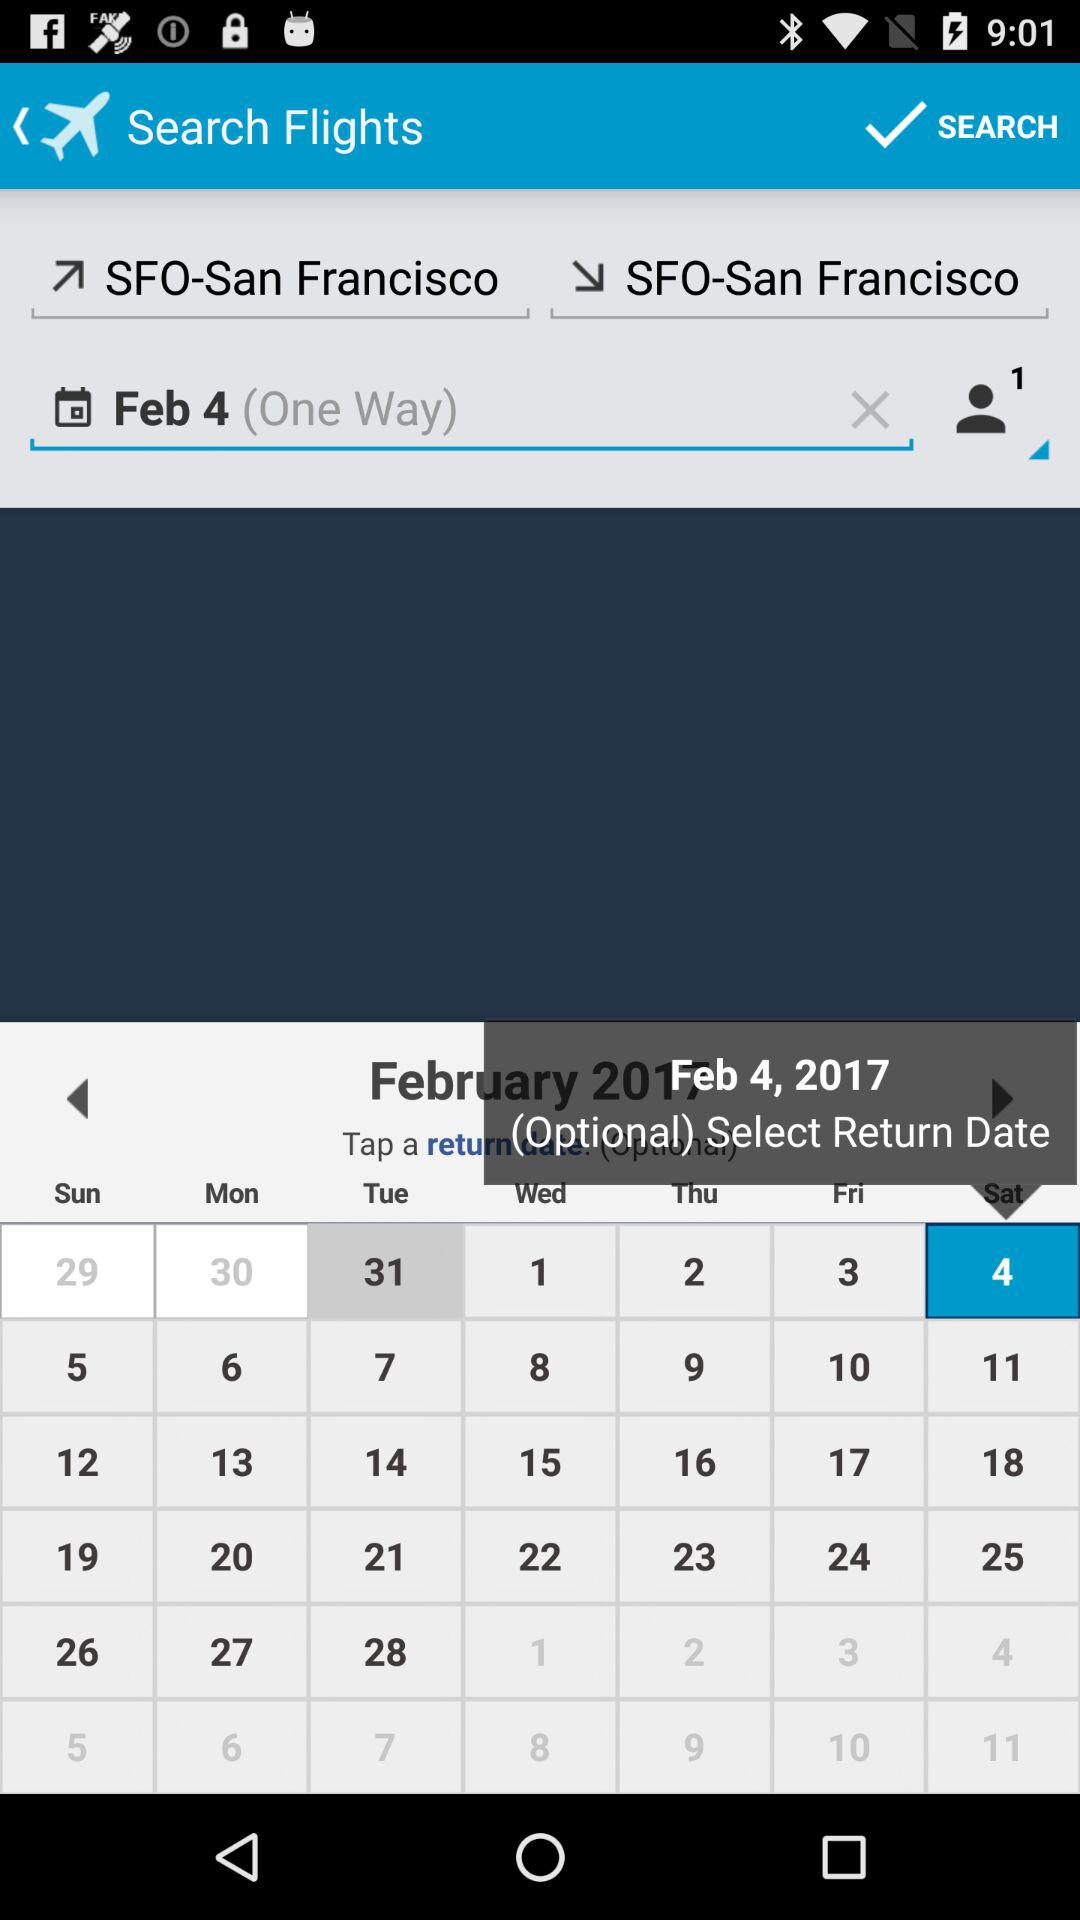What location is the flight search for? The flight search is for San Francisco. 